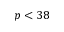Convert formula to latex. <formula><loc_0><loc_0><loc_500><loc_500>p < 3 8</formula> 